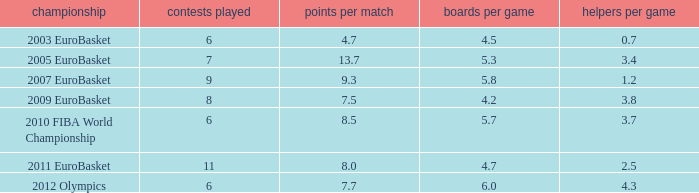How many games played have 4.7 as points per game? 6.0. 